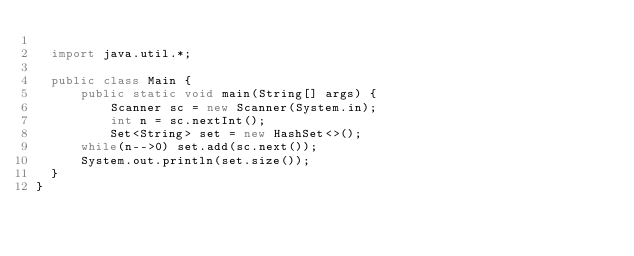Convert code to text. <code><loc_0><loc_0><loc_500><loc_500><_Java_>	
	import java.util.*;
	
	public class Main {
	    public static void main(String[] args) {
	        Scanner sc = new Scanner(System.in);
	        int n = sc.nextInt();
	        Set<String> set = new HashSet<>();
			while(n-->0) set.add(sc.next());
			System.out.println(set.size());
	}
}
	</code> 